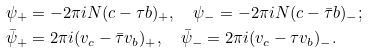<formula> <loc_0><loc_0><loc_500><loc_500>\psi _ { + } & = - 2 \pi i N ( c - \tau b ) _ { + } , \quad \psi _ { - } = - 2 \pi i N ( c - \bar { \tau } b ) _ { - } ; \\ \bar { \psi } _ { + } & = 2 \pi i ( v _ { c } - \bar { \tau } v _ { b } ) _ { + } , \quad \bar { \psi } _ { - } = 2 \pi i ( v _ { c } - \tau v _ { b } ) _ { - } .</formula> 